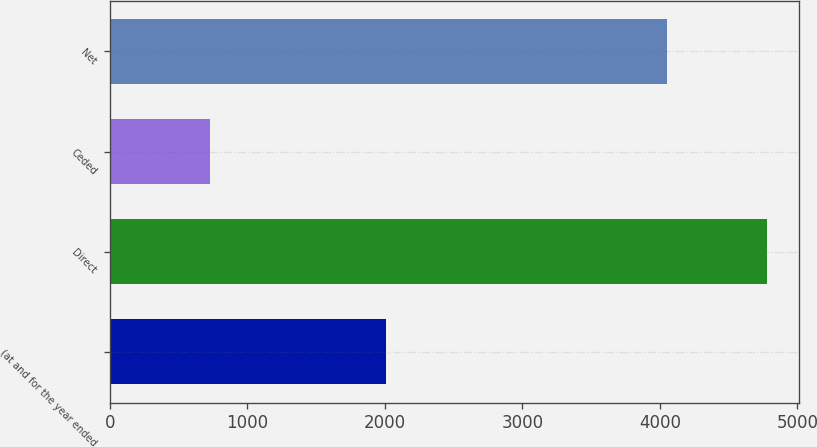Convert chart to OTSL. <chart><loc_0><loc_0><loc_500><loc_500><bar_chart><fcel>(at and for the year ended<fcel>Direct<fcel>Ceded<fcel>Net<nl><fcel>2007<fcel>4777<fcel>726<fcel>4051<nl></chart> 